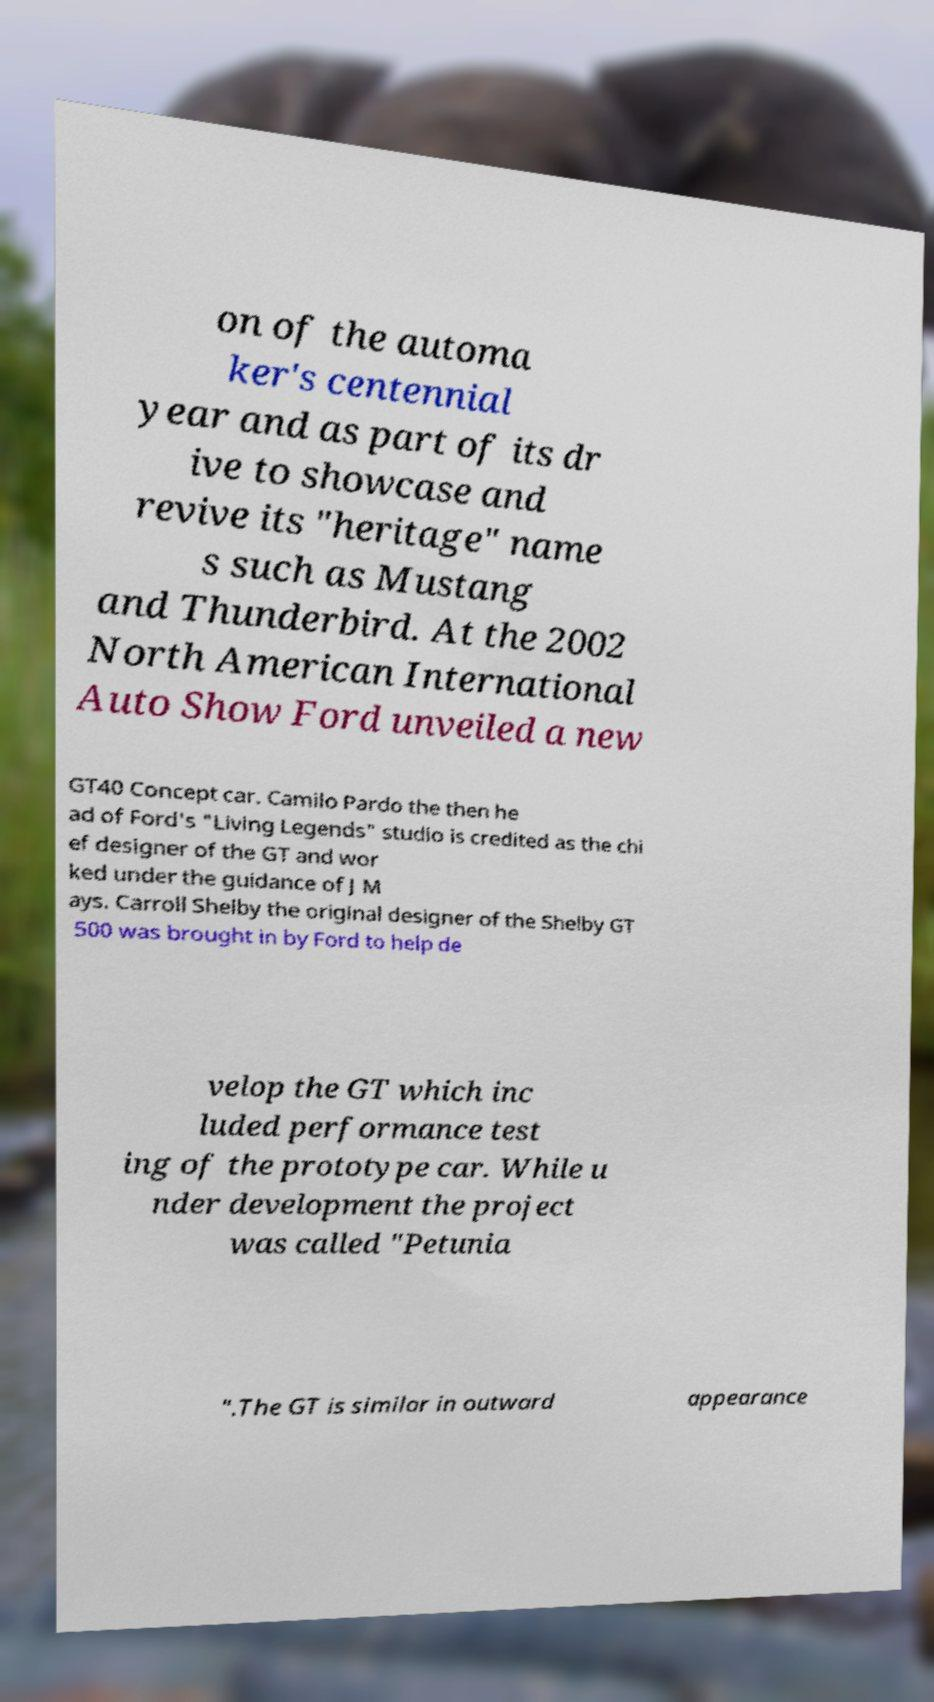Can you accurately transcribe the text from the provided image for me? on of the automa ker's centennial year and as part of its dr ive to showcase and revive its "heritage" name s such as Mustang and Thunderbird. At the 2002 North American International Auto Show Ford unveiled a new GT40 Concept car. Camilo Pardo the then he ad of Ford's "Living Legends" studio is credited as the chi ef designer of the GT and wor ked under the guidance of J M ays. Carroll Shelby the original designer of the Shelby GT 500 was brought in by Ford to help de velop the GT which inc luded performance test ing of the prototype car. While u nder development the project was called "Petunia ".The GT is similar in outward appearance 